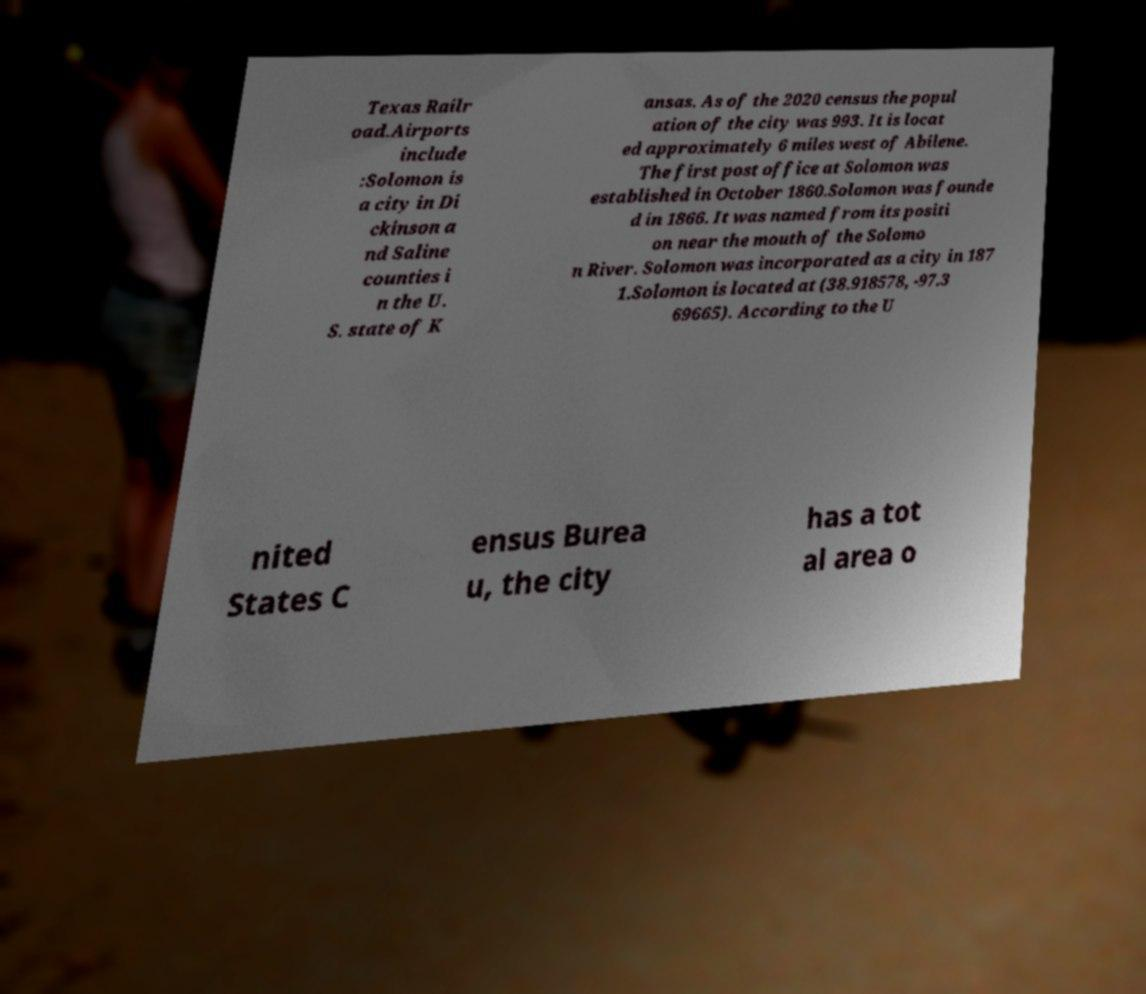There's text embedded in this image that I need extracted. Can you transcribe it verbatim? Texas Railr oad.Airports include :Solomon is a city in Di ckinson a nd Saline counties i n the U. S. state of K ansas. As of the 2020 census the popul ation of the city was 993. It is locat ed approximately 6 miles west of Abilene. The first post office at Solomon was established in October 1860.Solomon was founde d in 1866. It was named from its positi on near the mouth of the Solomo n River. Solomon was incorporated as a city in 187 1.Solomon is located at (38.918578, -97.3 69665). According to the U nited States C ensus Burea u, the city has a tot al area o 